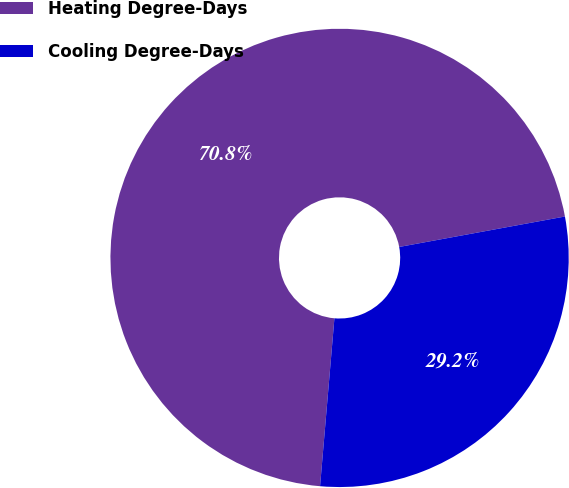Convert chart. <chart><loc_0><loc_0><loc_500><loc_500><pie_chart><fcel>Heating Degree-Days<fcel>Cooling Degree-Days<nl><fcel>70.75%<fcel>29.25%<nl></chart> 